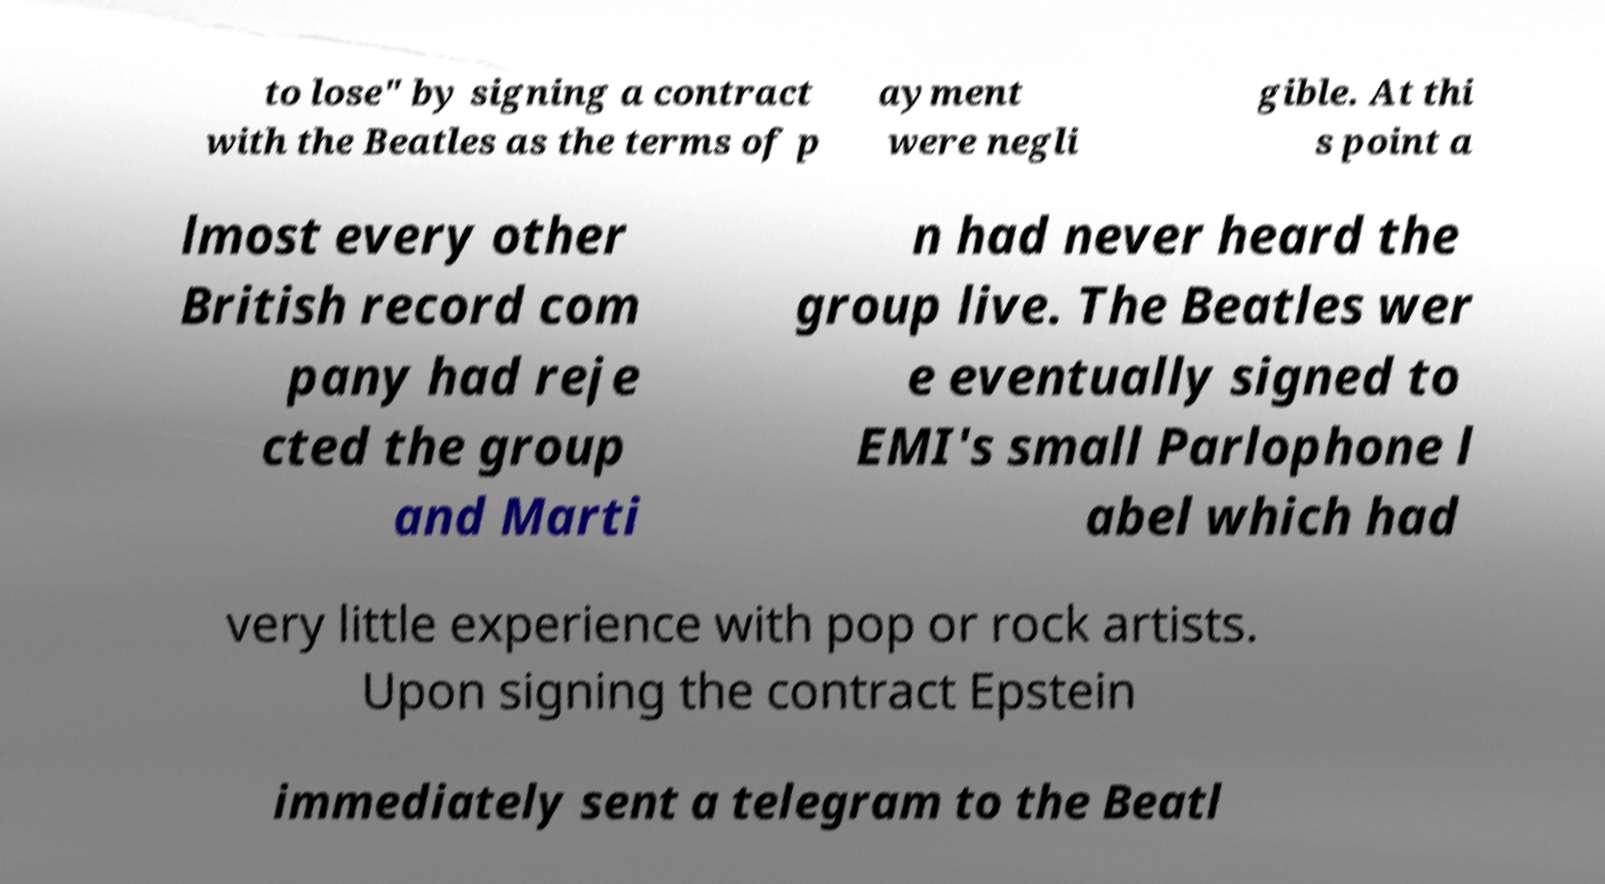Please identify and transcribe the text found in this image. to lose" by signing a contract with the Beatles as the terms of p ayment were negli gible. At thi s point a lmost every other British record com pany had reje cted the group and Marti n had never heard the group live. The Beatles wer e eventually signed to EMI's small Parlophone l abel which had very little experience with pop or rock artists. Upon signing the contract Epstein immediately sent a telegram to the Beatl 